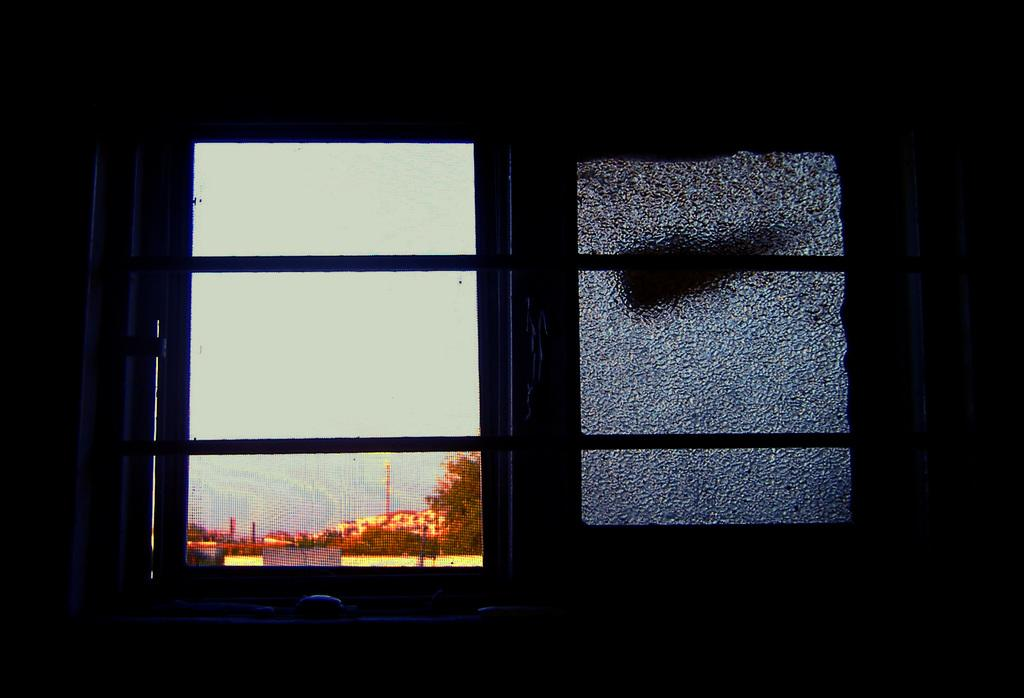What type of object is in the image that has a handle? There is a glass object in the image that has a handle. What are the rods on the glass object used for? The rods on the glass object are likely used for support or structure. What is the purpose of the mesh on the glass object? The mesh on the glass object allows for an outside view while still providing some level of privacy or protection. What can be seen through the mesh in the image? Trees, houses, poles, and the sky can be seen through the mesh in the image. How many bubbles are floating around the neck of the glass object in the image? There are no bubbles visible in the image, and the glass object does not have a neck. 